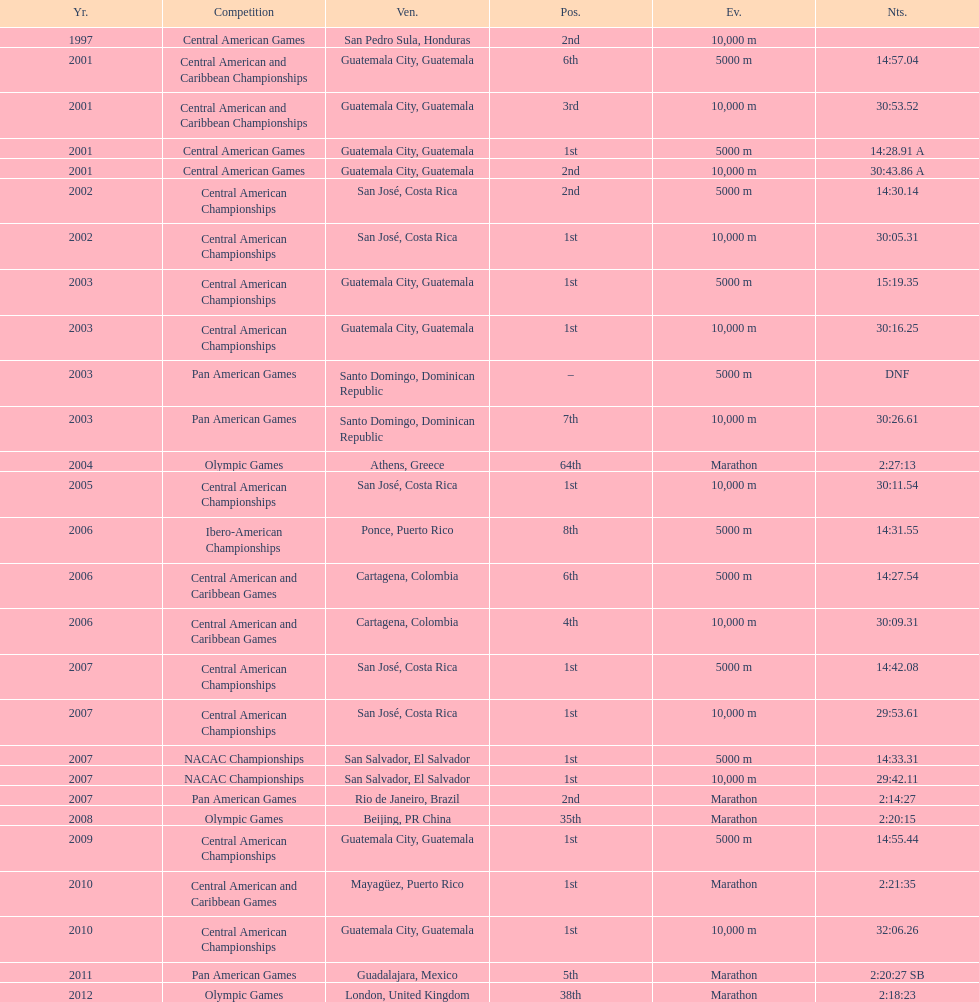The central american championships and what other competition occurred in 2010? Central American and Caribbean Games. 